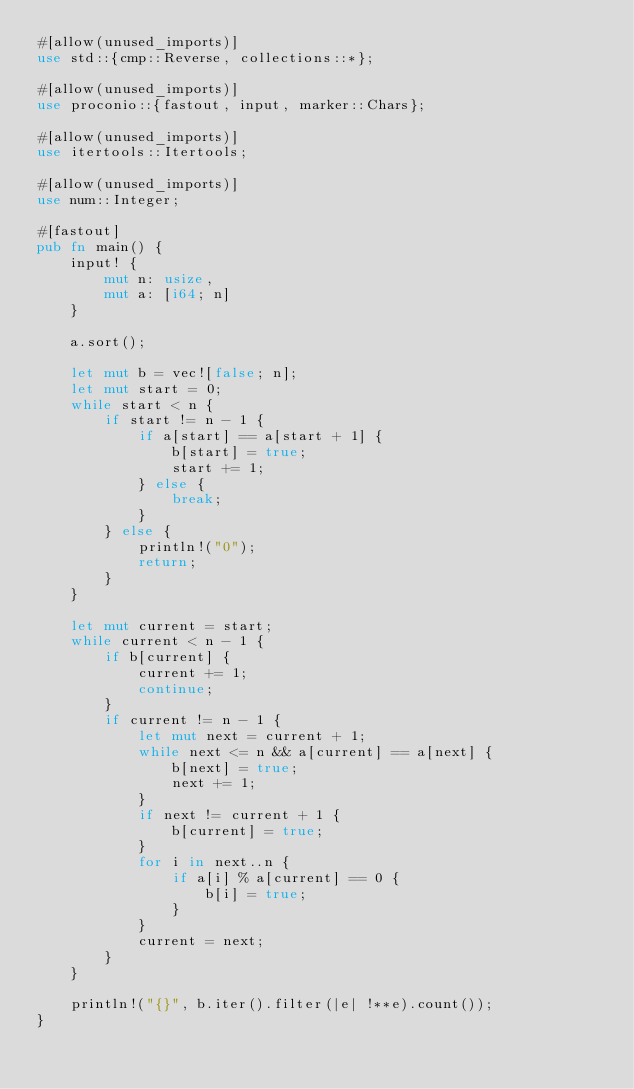Convert code to text. <code><loc_0><loc_0><loc_500><loc_500><_Rust_>#[allow(unused_imports)]
use std::{cmp::Reverse, collections::*};

#[allow(unused_imports)]
use proconio::{fastout, input, marker::Chars};

#[allow(unused_imports)]
use itertools::Itertools;

#[allow(unused_imports)]
use num::Integer;

#[fastout]
pub fn main() {
    input! {
        mut n: usize,
        mut a: [i64; n]
    }

    a.sort();

    let mut b = vec![false; n];
    let mut start = 0;
    while start < n {
        if start != n - 1 {
            if a[start] == a[start + 1] {
                b[start] = true;
                start += 1;
            } else {
                break;
            }
        } else {
            println!("0");
            return;
        }
    }

    let mut current = start;
    while current < n - 1 {
        if b[current] {
            current += 1;
            continue;
        }
        if current != n - 1 {
            let mut next = current + 1;
            while next <= n && a[current] == a[next] {
                b[next] = true;
                next += 1;
            }
            if next != current + 1 {
                b[current] = true;
            }
            for i in next..n {
                if a[i] % a[current] == 0 {
                    b[i] = true;
                }
            }
            current = next;
        }
    }

    println!("{}", b.iter().filter(|e| !**e).count());
}
</code> 